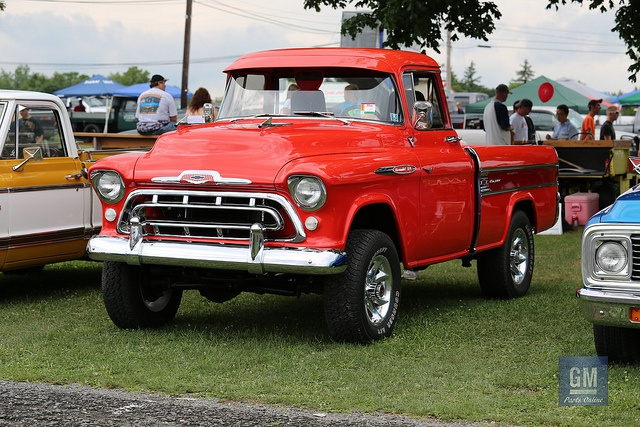Describe the objects in this image and their specific colors. I can see truck in lightgray, black, brown, red, and salmon tones, truck in lightgray, darkgray, black, maroon, and olive tones, truck in lightgray, black, gray, and darkgray tones, car in lightgray, black, gray, and darkgray tones, and people in lightgray, darkgray, gray, and black tones in this image. 